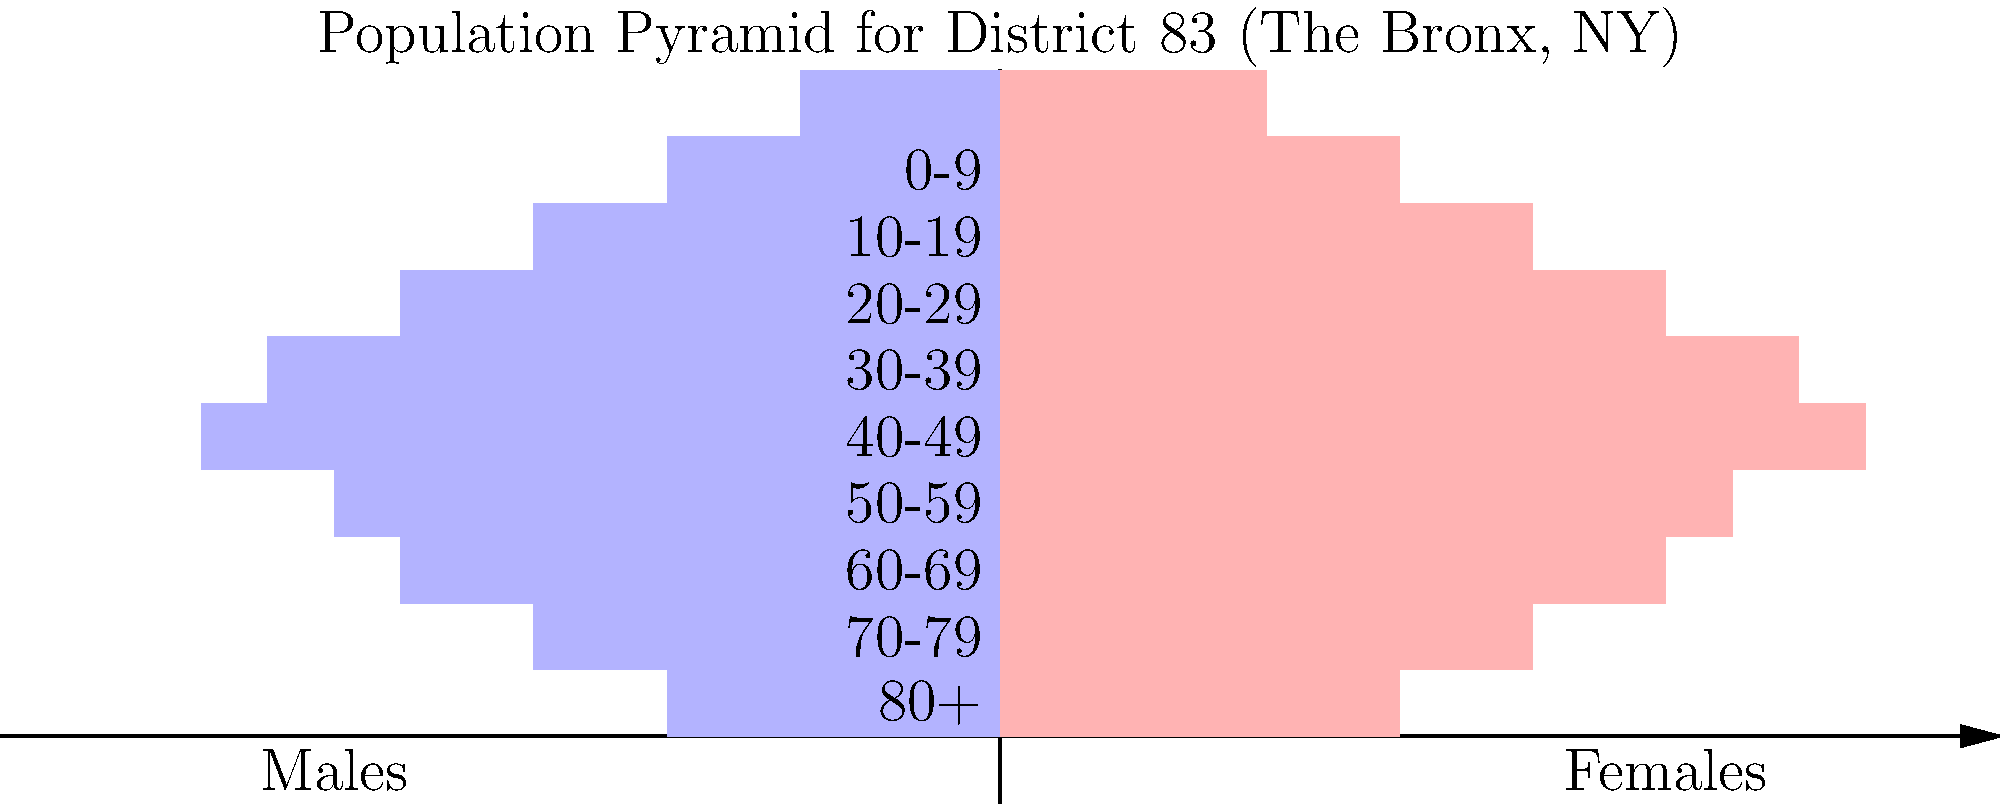Based on the population pyramid for District 83 in The Bronx, NY, which age group shows the highest percentage of the population for both males and females combined? To determine the age group with the highest percentage of the population for both males and females combined, we need to follow these steps:

1. Identify the longest bars on both sides of the pyramid, as these represent the largest population groups.
2. Compare the combined length of the male and female bars for each age group.
3. The age group with the longest combined bar length represents the highest percentage of the population.

Looking at the population pyramid:

1. The longest bars appear to be in the middle of the pyramid.
2. The age group with the longest bars for both males and females is the "40-49" category.
3. For the "40-49" age group:
   - The male bar extends to about 12 units
   - The female bar extends to about 13 units
   - Combined, this gives the largest total of approximately 25 units

No other age group has a combined bar length that exceeds this total.

Therefore, the age group 40-49 years old represents the highest percentage of the population in District 83 for both males and females combined.
Answer: 40-49 years old 